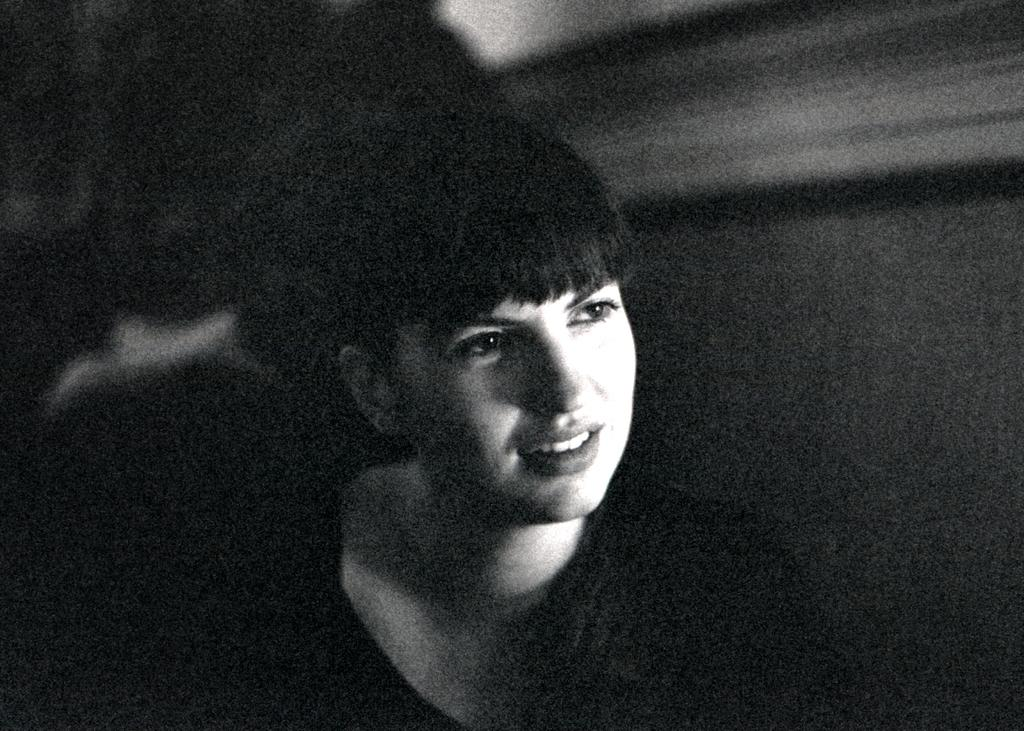What is the main subject of the image? The main subject of the image is a woman. What is the woman doing in the image? The woman is standing in the image. What is the woman's facial expression in the image? The woman is smiling in the image. What type of button can be seen on the woman's shirt in the image? There is no button visible on the woman's shirt in the image. What emotion does the woman display other than happiness in the image? The woman is only displaying happiness (smiling) in the image, and there is no indication of any other emotion. 